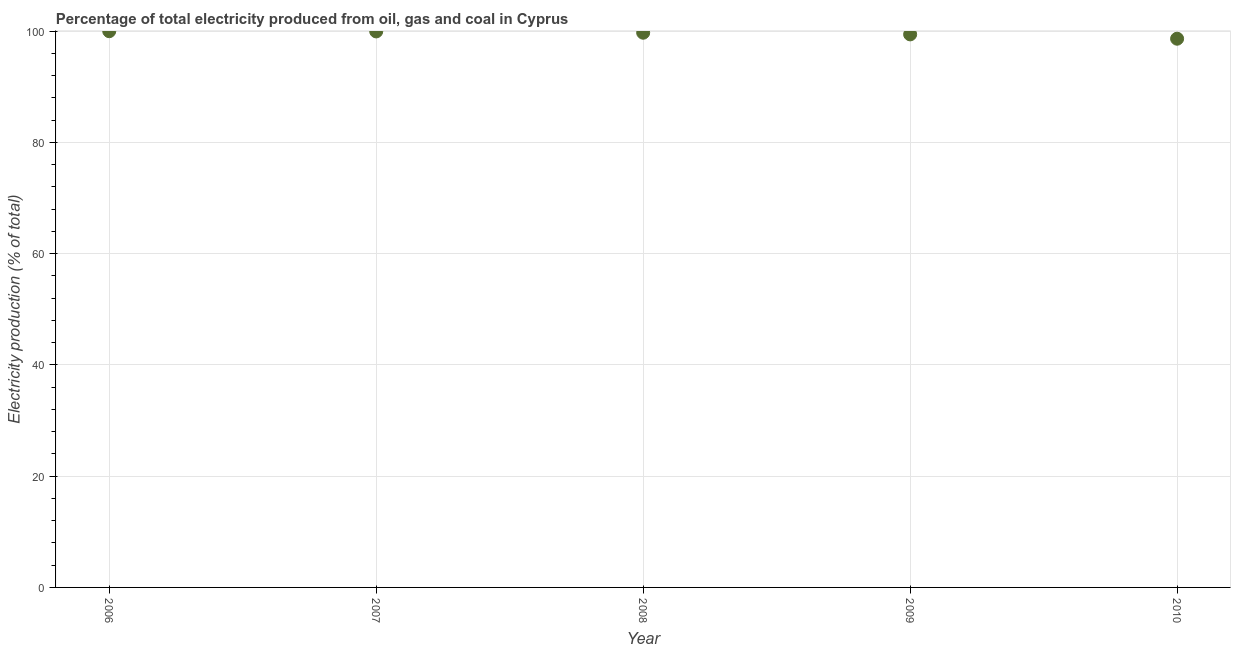What is the electricity production in 2009?
Keep it short and to the point. 99.41. Across all years, what is the maximum electricity production?
Provide a succinct answer. 99.98. Across all years, what is the minimum electricity production?
Ensure brevity in your answer.  98.63. In which year was the electricity production minimum?
Keep it short and to the point. 2010. What is the sum of the electricity production?
Your answer should be very brief. 497.66. What is the difference between the electricity production in 2007 and 2009?
Provide a short and direct response. 0.53. What is the average electricity production per year?
Ensure brevity in your answer.  99.53. What is the median electricity production?
Your response must be concise. 99.7. In how many years, is the electricity production greater than 68 %?
Give a very brief answer. 5. Do a majority of the years between 2006 and 2008 (inclusive) have electricity production greater than 8 %?
Make the answer very short. Yes. What is the ratio of the electricity production in 2006 to that in 2009?
Ensure brevity in your answer.  1.01. What is the difference between the highest and the second highest electricity production?
Make the answer very short. 0.04. Is the sum of the electricity production in 2007 and 2010 greater than the maximum electricity production across all years?
Offer a terse response. Yes. What is the difference between the highest and the lowest electricity production?
Your answer should be compact. 1.35. How many dotlines are there?
Keep it short and to the point. 1. How many years are there in the graph?
Make the answer very short. 5. What is the difference between two consecutive major ticks on the Y-axis?
Your answer should be very brief. 20. Does the graph contain grids?
Your response must be concise. Yes. What is the title of the graph?
Give a very brief answer. Percentage of total electricity produced from oil, gas and coal in Cyprus. What is the label or title of the X-axis?
Make the answer very short. Year. What is the label or title of the Y-axis?
Your answer should be very brief. Electricity production (% of total). What is the Electricity production (% of total) in 2006?
Offer a very short reply. 99.98. What is the Electricity production (% of total) in 2007?
Provide a short and direct response. 99.94. What is the Electricity production (% of total) in 2008?
Provide a short and direct response. 99.7. What is the Electricity production (% of total) in 2009?
Ensure brevity in your answer.  99.41. What is the Electricity production (% of total) in 2010?
Your response must be concise. 98.63. What is the difference between the Electricity production (% of total) in 2006 and 2007?
Provide a succinct answer. 0.04. What is the difference between the Electricity production (% of total) in 2006 and 2008?
Offer a very short reply. 0.27. What is the difference between the Electricity production (% of total) in 2006 and 2009?
Keep it short and to the point. 0.57. What is the difference between the Electricity production (% of total) in 2006 and 2010?
Provide a short and direct response. 1.35. What is the difference between the Electricity production (% of total) in 2007 and 2008?
Keep it short and to the point. 0.23. What is the difference between the Electricity production (% of total) in 2007 and 2009?
Give a very brief answer. 0.53. What is the difference between the Electricity production (% of total) in 2007 and 2010?
Your response must be concise. 1.31. What is the difference between the Electricity production (% of total) in 2008 and 2009?
Keep it short and to the point. 0.3. What is the difference between the Electricity production (% of total) in 2008 and 2010?
Offer a terse response. 1.08. What is the difference between the Electricity production (% of total) in 2009 and 2010?
Give a very brief answer. 0.78. What is the ratio of the Electricity production (% of total) in 2006 to that in 2007?
Your answer should be compact. 1. What is the ratio of the Electricity production (% of total) in 2006 to that in 2008?
Keep it short and to the point. 1. What is the ratio of the Electricity production (% of total) in 2006 to that in 2010?
Give a very brief answer. 1.01. What is the ratio of the Electricity production (% of total) in 2007 to that in 2008?
Provide a short and direct response. 1. What is the ratio of the Electricity production (% of total) in 2007 to that in 2009?
Make the answer very short. 1. 